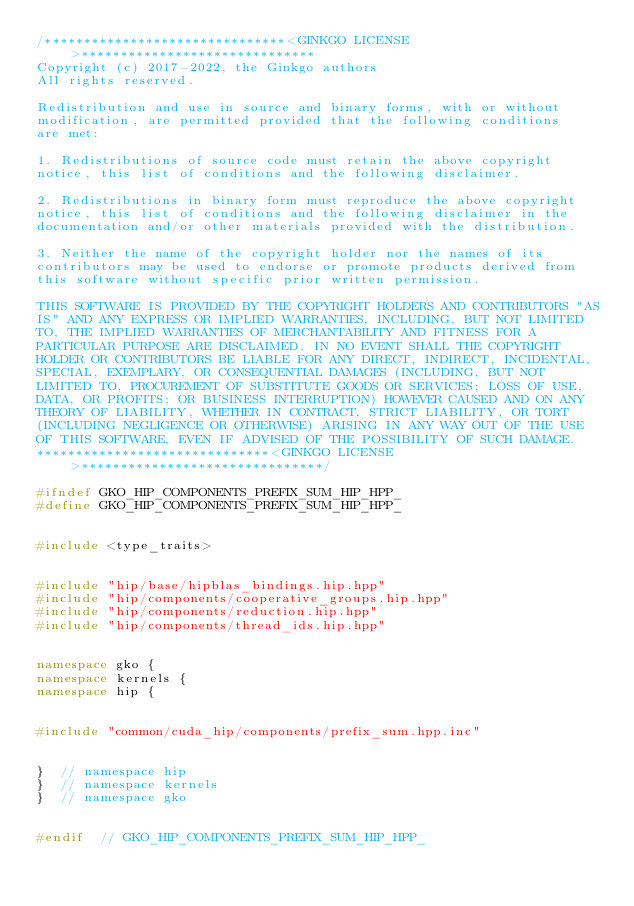Convert code to text. <code><loc_0><loc_0><loc_500><loc_500><_C++_>/*******************************<GINKGO LICENSE>******************************
Copyright (c) 2017-2022, the Ginkgo authors
All rights reserved.

Redistribution and use in source and binary forms, with or without
modification, are permitted provided that the following conditions
are met:

1. Redistributions of source code must retain the above copyright
notice, this list of conditions and the following disclaimer.

2. Redistributions in binary form must reproduce the above copyright
notice, this list of conditions and the following disclaimer in the
documentation and/or other materials provided with the distribution.

3. Neither the name of the copyright holder nor the names of its
contributors may be used to endorse or promote products derived from
this software without specific prior written permission.

THIS SOFTWARE IS PROVIDED BY THE COPYRIGHT HOLDERS AND CONTRIBUTORS "AS
IS" AND ANY EXPRESS OR IMPLIED WARRANTIES, INCLUDING, BUT NOT LIMITED
TO, THE IMPLIED WARRANTIES OF MERCHANTABILITY AND FITNESS FOR A
PARTICULAR PURPOSE ARE DISCLAIMED. IN NO EVENT SHALL THE COPYRIGHT
HOLDER OR CONTRIBUTORS BE LIABLE FOR ANY DIRECT, INDIRECT, INCIDENTAL,
SPECIAL, EXEMPLARY, OR CONSEQUENTIAL DAMAGES (INCLUDING, BUT NOT
LIMITED TO, PROCUREMENT OF SUBSTITUTE GOODS OR SERVICES; LOSS OF USE,
DATA, OR PROFITS; OR BUSINESS INTERRUPTION) HOWEVER CAUSED AND ON ANY
THEORY OF LIABILITY, WHETHER IN CONTRACT, STRICT LIABILITY, OR TORT
(INCLUDING NEGLIGENCE OR OTHERWISE) ARISING IN ANY WAY OUT OF THE USE
OF THIS SOFTWARE, EVEN IF ADVISED OF THE POSSIBILITY OF SUCH DAMAGE.
******************************<GINKGO LICENSE>*******************************/

#ifndef GKO_HIP_COMPONENTS_PREFIX_SUM_HIP_HPP_
#define GKO_HIP_COMPONENTS_PREFIX_SUM_HIP_HPP_


#include <type_traits>


#include "hip/base/hipblas_bindings.hip.hpp"
#include "hip/components/cooperative_groups.hip.hpp"
#include "hip/components/reduction.hip.hpp"
#include "hip/components/thread_ids.hip.hpp"


namespace gko {
namespace kernels {
namespace hip {


#include "common/cuda_hip/components/prefix_sum.hpp.inc"


}  // namespace hip
}  // namespace kernels
}  // namespace gko


#endif  // GKO_HIP_COMPONENTS_PREFIX_SUM_HIP_HPP_
</code> 